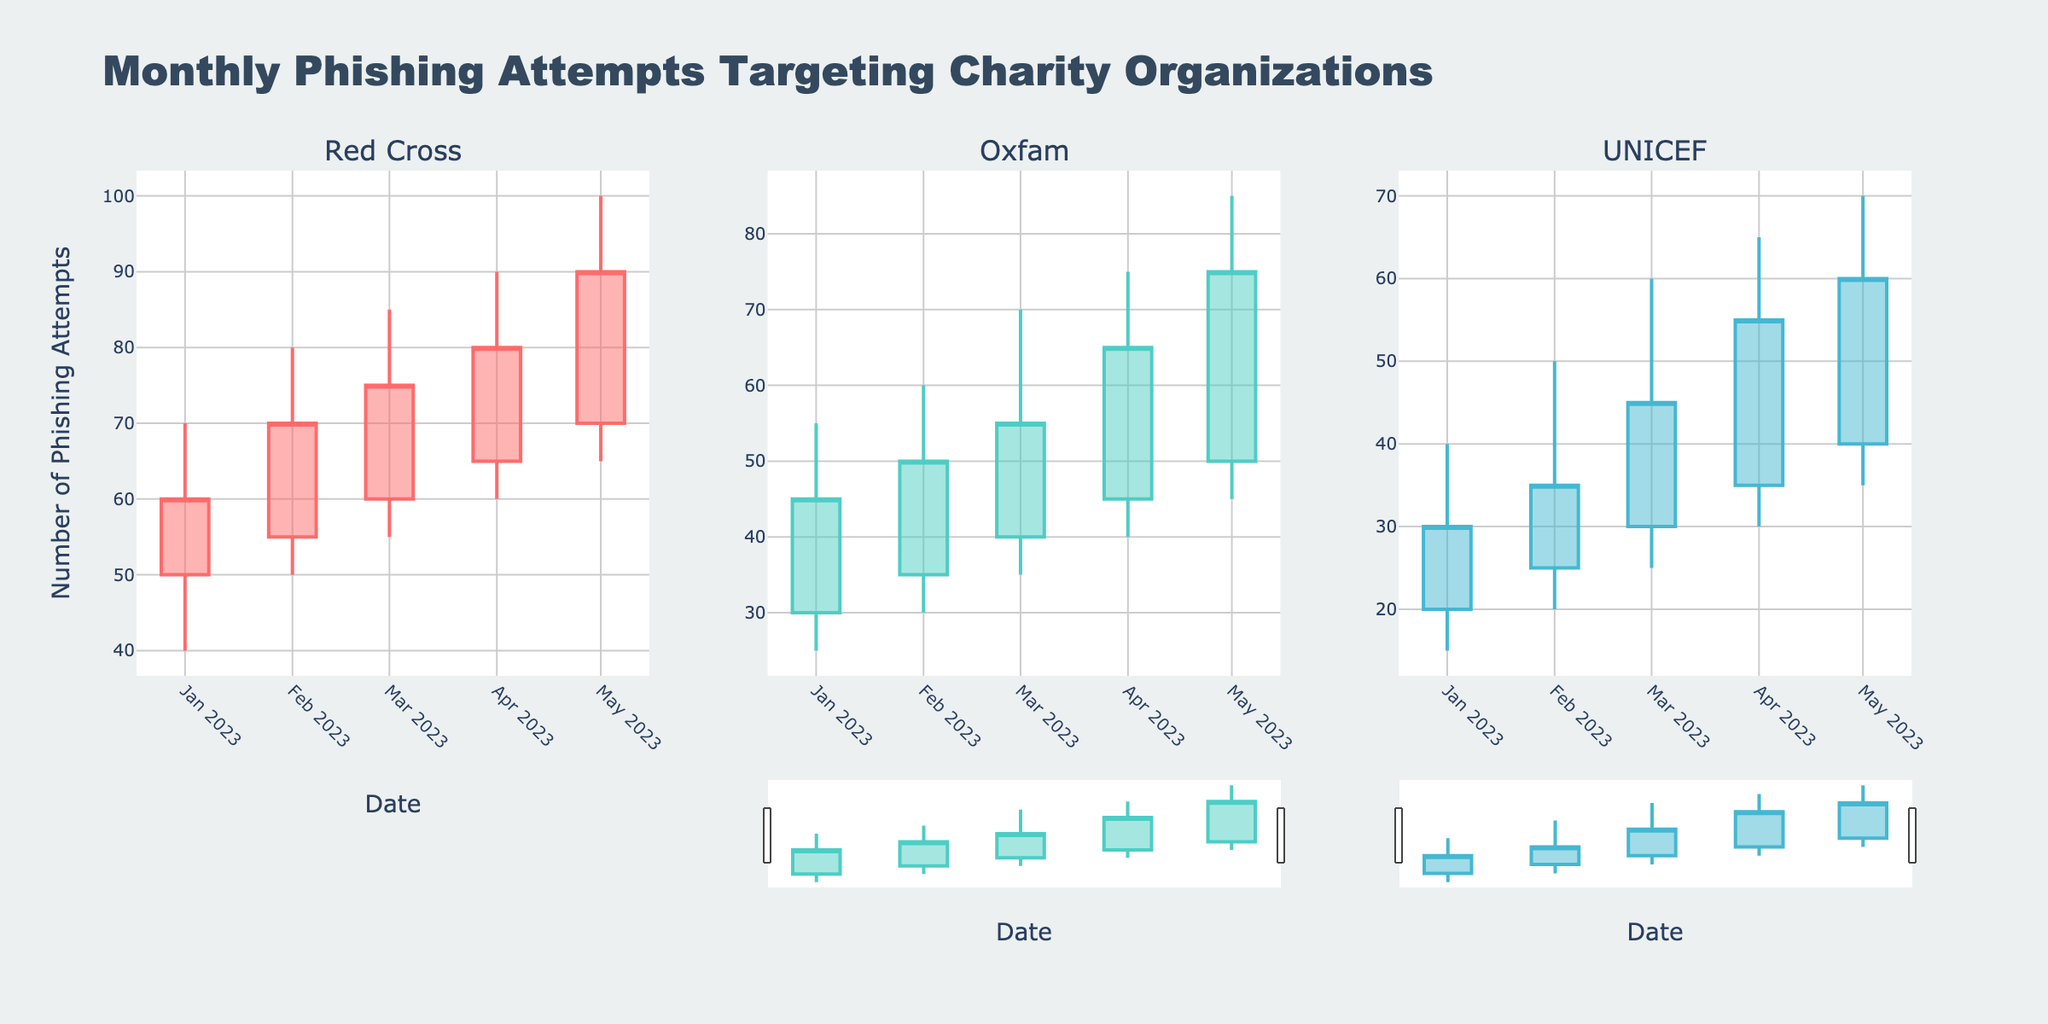What's the title of the figure? The title of the figure is displayed at the top of the plot, summarizing its content.
Answer: Monthly Phishing Attempts Targeting Charity Organizations What period does the x-axis cover? The x-axis shows the dates ranging from January 1, 2023, to May 1, 2023.
Answer: January 2023 to May 2023 What is the highest recorded number of phishing attempts for the Red Cross in the given period? By looking at the highest vertical bar in the Red Cross subplot, we see that the maximum value on the y-axis for Red Cross reaches 100 in May 2023.
Answer: 100 Between Oxfam and UNICEF, which organization had a higher closing value in April 2023? For April 2023, Oxfam's closing value is 65, and UNICEF's closing value is 55. Oxfam has a higher closing value.
Answer: Oxfam Which organization experienced the largest increase in phishing attempts from January to May 2023? To determine the largest increase, we look for the difference between the closing values in January and May. Red Cross increased from 60 to 90 (a rise of 30), Oxfam from 45 to 75 (a rise of 30), and UNICEF from 30 to 60 (a rise of 30). Therefore, all organizations experienced the same increase.
Answer: All organizations What was the lowest recorded number of phishing attempts for UNICEF in the given period? By examining the lowest point of the candlestick plot for UNICEF, we see the lowest value was 15 in January 2023.
Answer: 15 In which month did the Red Cross experience the highest range of phishing attempts? The range is the difference between the high and low values. For Red Cross, this is largest in May 2023 with a high of 100 and a low of 65, resulting in a range of 35.
Answer: May 2023 Did Oxfam ever have a month where the closing number of phishing attempts was lower than the opening number? By observing the candlestick for Oxfam, we check if the lower box part is present. In all cases, the closing value is higher or equal to the opening value, indicating no month had a closing number lower than the opening number.
Answer: No Comparing March 2023, which organization had the smallest difference between their high and low values? The differences for March 2023 are as follows: Red Cross (30), Oxfam (35), UNICEF (35). Red Cross has the smallest difference.
Answer: Red Cross 